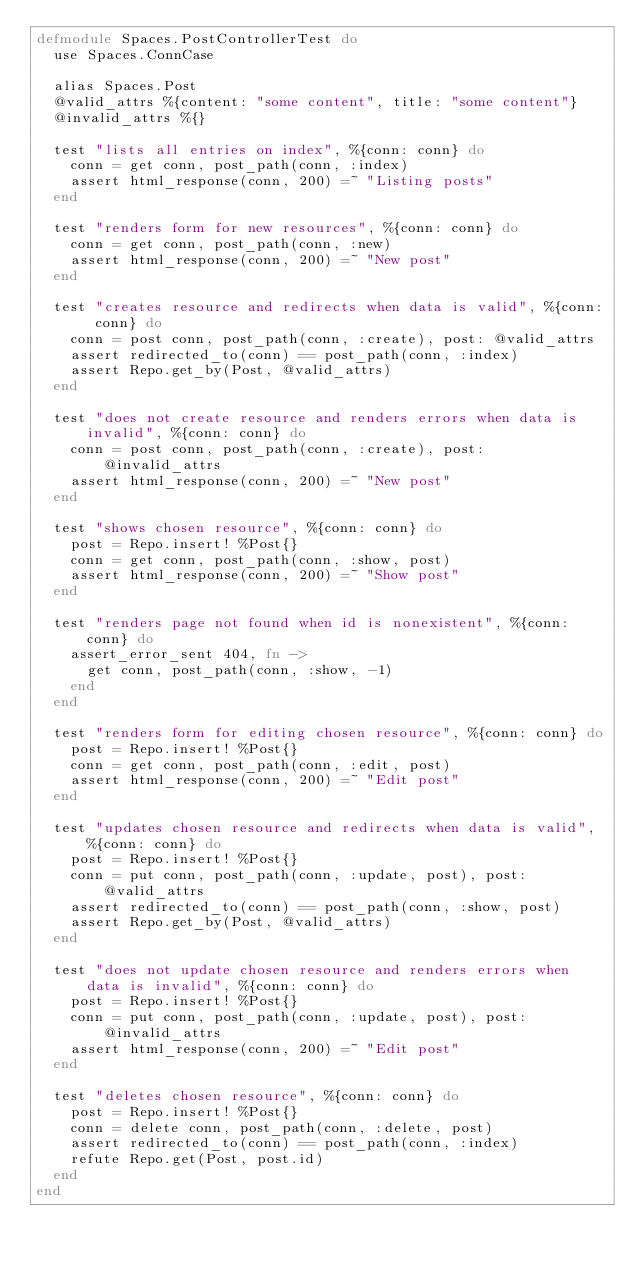<code> <loc_0><loc_0><loc_500><loc_500><_Elixir_>defmodule Spaces.PostControllerTest do
  use Spaces.ConnCase

  alias Spaces.Post
  @valid_attrs %{content: "some content", title: "some content"}
  @invalid_attrs %{}

  test "lists all entries on index", %{conn: conn} do
    conn = get conn, post_path(conn, :index)
    assert html_response(conn, 200) =~ "Listing posts"
  end

  test "renders form for new resources", %{conn: conn} do
    conn = get conn, post_path(conn, :new)
    assert html_response(conn, 200) =~ "New post"
  end

  test "creates resource and redirects when data is valid", %{conn: conn} do
    conn = post conn, post_path(conn, :create), post: @valid_attrs
    assert redirected_to(conn) == post_path(conn, :index)
    assert Repo.get_by(Post, @valid_attrs)
  end

  test "does not create resource and renders errors when data is invalid", %{conn: conn} do
    conn = post conn, post_path(conn, :create), post: @invalid_attrs
    assert html_response(conn, 200) =~ "New post"
  end

  test "shows chosen resource", %{conn: conn} do
    post = Repo.insert! %Post{}
    conn = get conn, post_path(conn, :show, post)
    assert html_response(conn, 200) =~ "Show post"
  end

  test "renders page not found when id is nonexistent", %{conn: conn} do
    assert_error_sent 404, fn ->
      get conn, post_path(conn, :show, -1)
    end
  end

  test "renders form for editing chosen resource", %{conn: conn} do
    post = Repo.insert! %Post{}
    conn = get conn, post_path(conn, :edit, post)
    assert html_response(conn, 200) =~ "Edit post"
  end

  test "updates chosen resource and redirects when data is valid", %{conn: conn} do
    post = Repo.insert! %Post{}
    conn = put conn, post_path(conn, :update, post), post: @valid_attrs
    assert redirected_to(conn) == post_path(conn, :show, post)
    assert Repo.get_by(Post, @valid_attrs)
  end

  test "does not update chosen resource and renders errors when data is invalid", %{conn: conn} do
    post = Repo.insert! %Post{}
    conn = put conn, post_path(conn, :update, post), post: @invalid_attrs
    assert html_response(conn, 200) =~ "Edit post"
  end

  test "deletes chosen resource", %{conn: conn} do
    post = Repo.insert! %Post{}
    conn = delete conn, post_path(conn, :delete, post)
    assert redirected_to(conn) == post_path(conn, :index)
    refute Repo.get(Post, post.id)
  end
end
</code> 